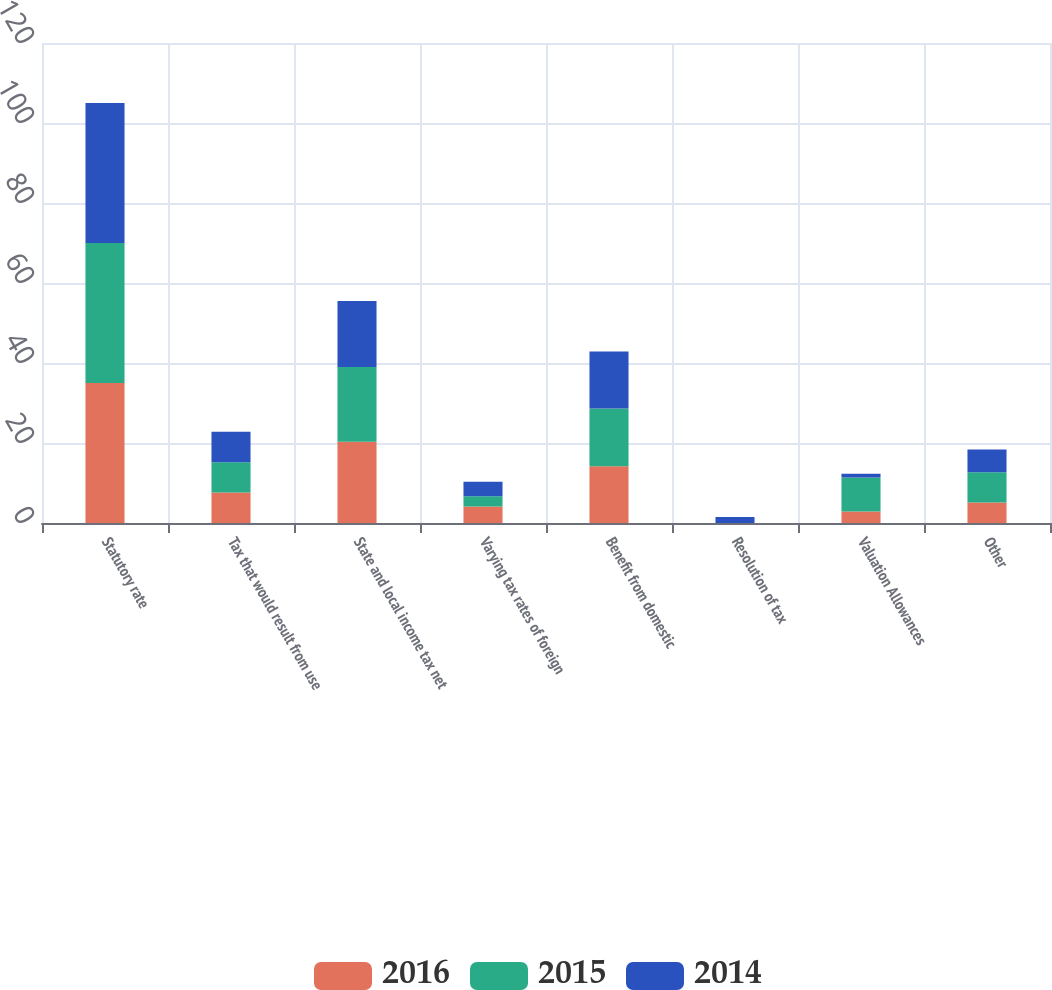<chart> <loc_0><loc_0><loc_500><loc_500><stacked_bar_chart><ecel><fcel>Statutory rate<fcel>Tax that would result from use<fcel>State and local income tax net<fcel>Varying tax rates of foreign<fcel>Benefit from domestic<fcel>Resolution of tax<fcel>Valuation Allowances<fcel>Other<nl><fcel>2016<fcel>35<fcel>7.6<fcel>20.3<fcel>4.1<fcel>14.2<fcel>0<fcel>2.9<fcel>5.1<nl><fcel>2015<fcel>35<fcel>7.6<fcel>18.7<fcel>2.6<fcel>14.4<fcel>0<fcel>8.5<fcel>7.6<nl><fcel>2014<fcel>35<fcel>7.6<fcel>16.5<fcel>3.6<fcel>14.3<fcel>1.5<fcel>0.9<fcel>5.7<nl></chart> 